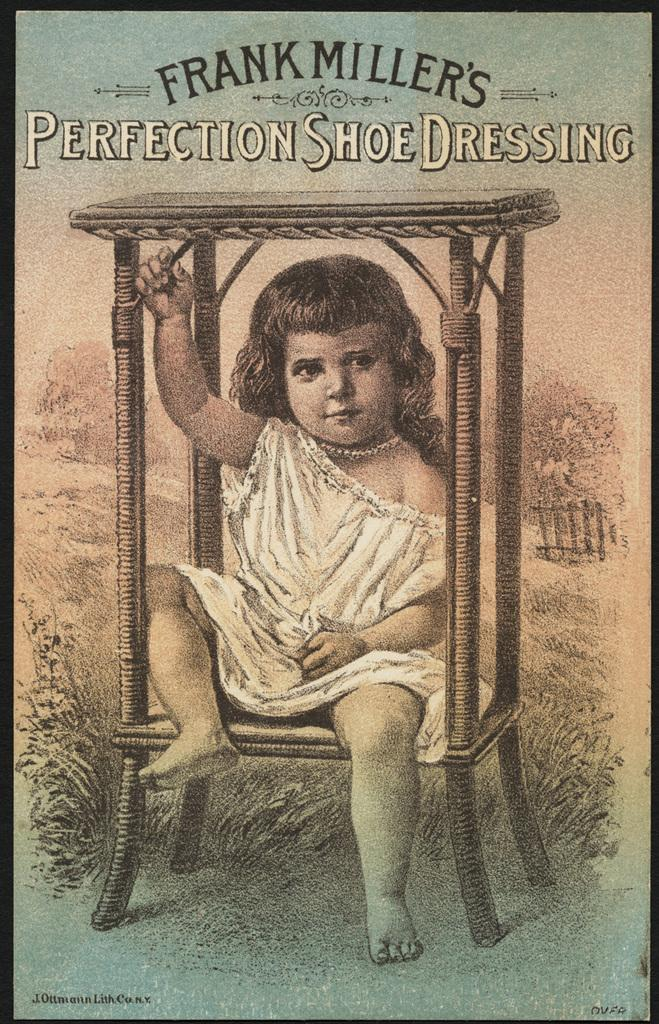<image>
Give a short and clear explanation of the subsequent image. On a poster for Frank Miller's perfection shoe dressing, is a little girl sitting on a wicker chair. 